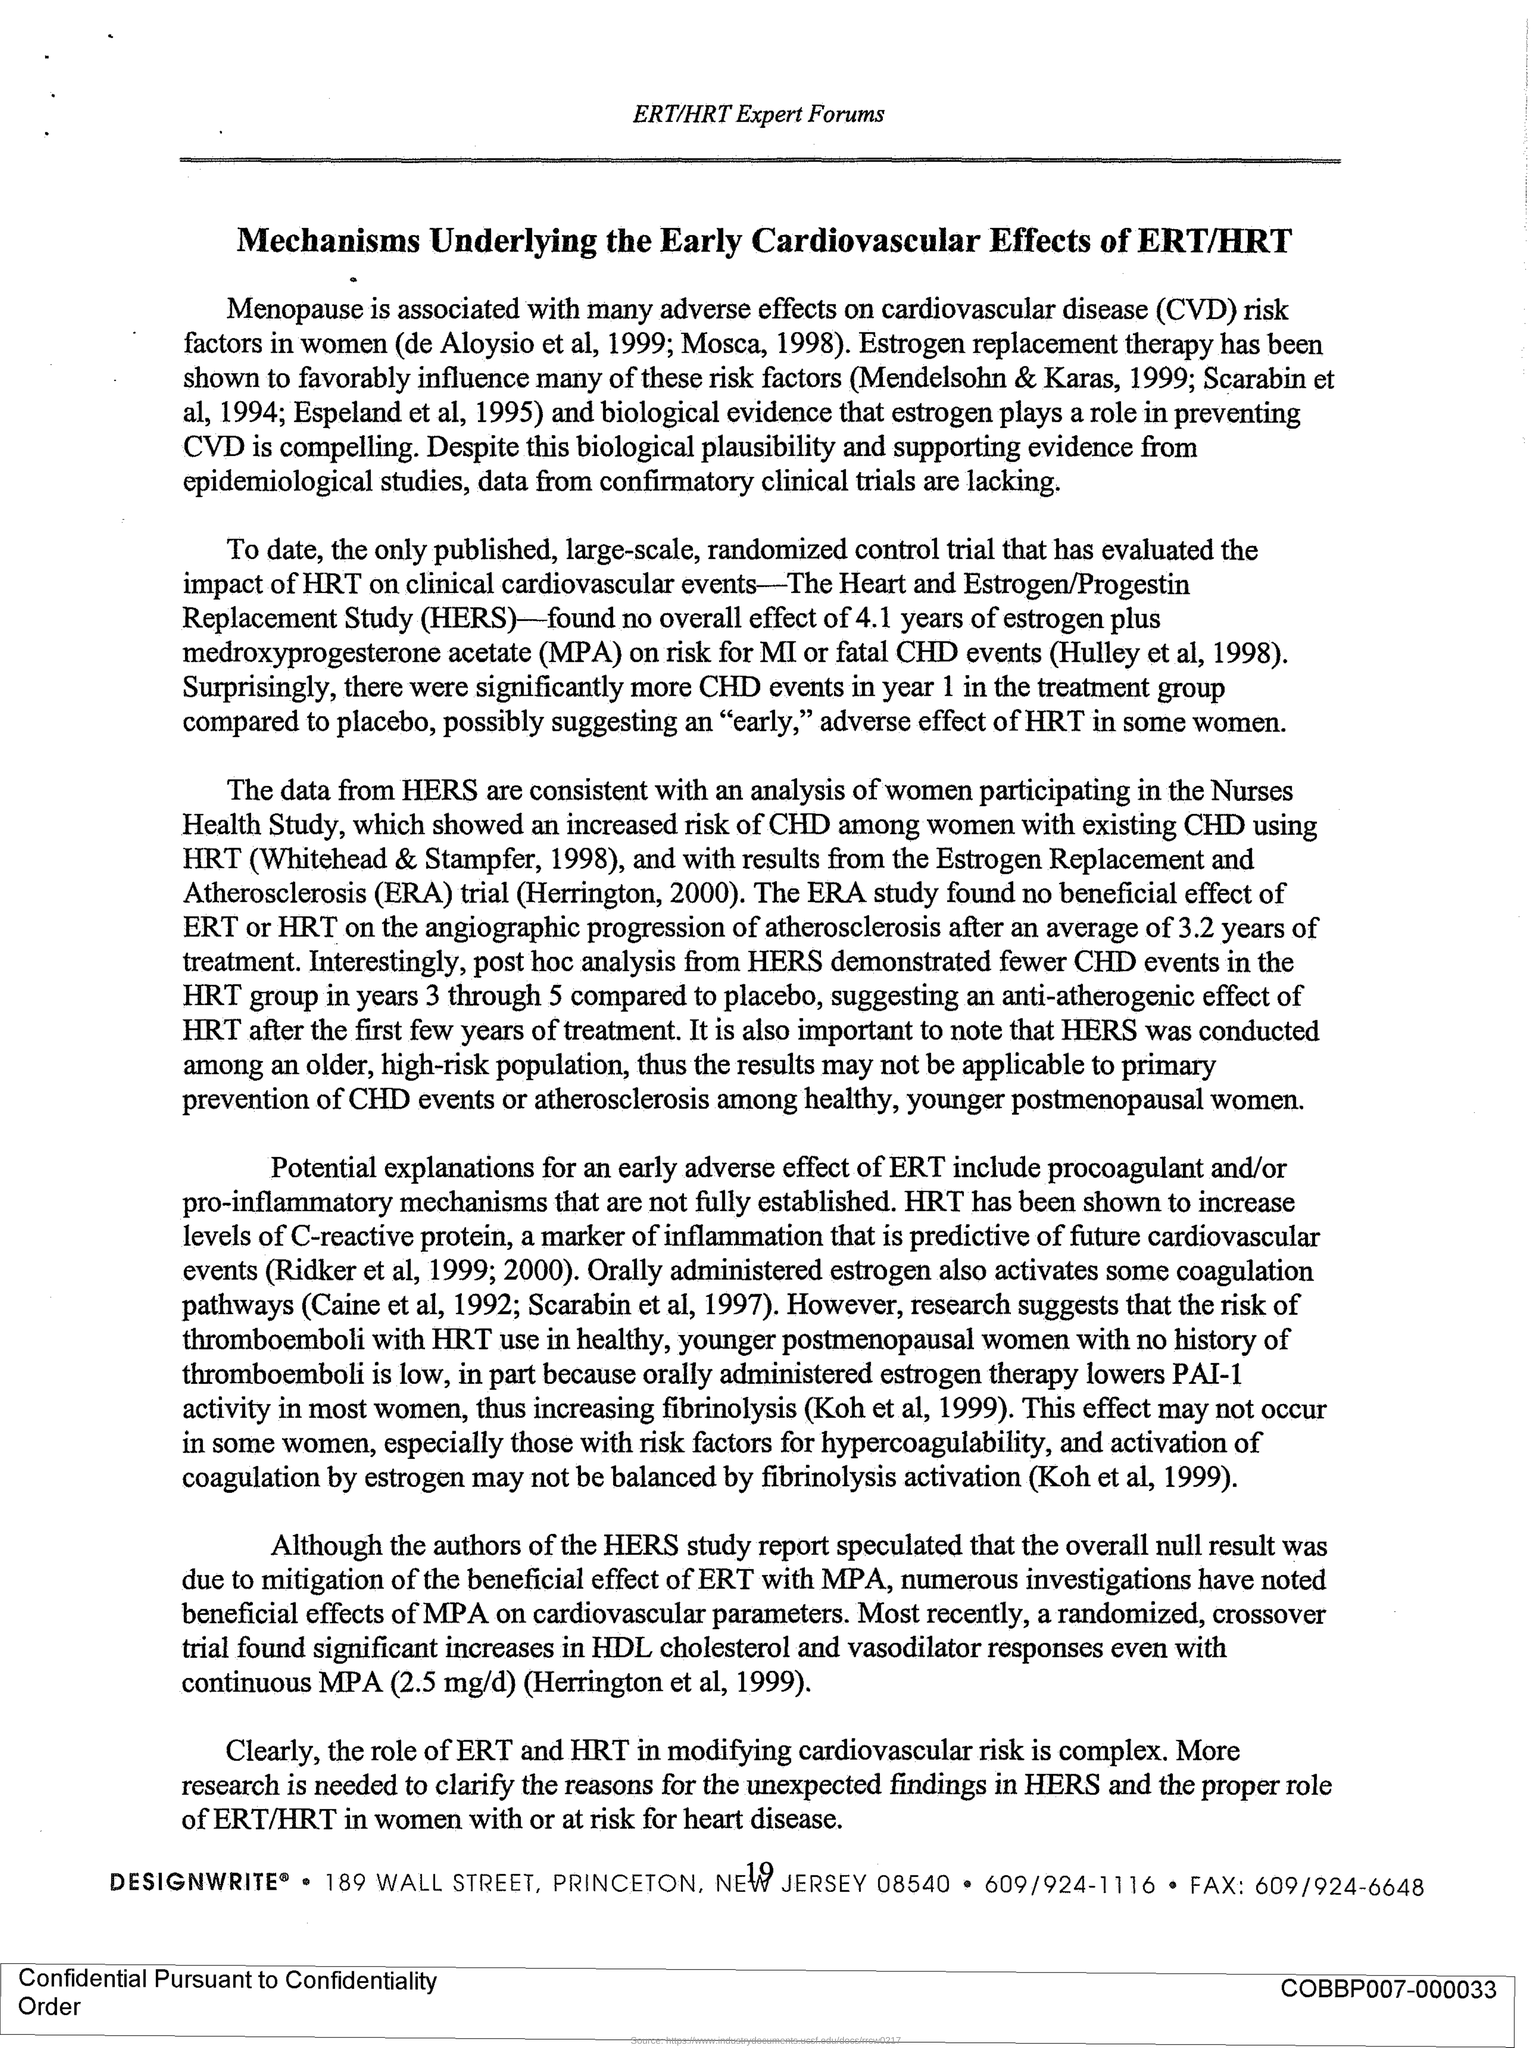What is the title of this document?
Your answer should be compact. Mechanisms Underlying the Early Cardiovascular Effects of ERT/HRT. What is the fullform of CVD?
Give a very brief answer. Cardiovascular disease. What is the abbreviation for 'The Heart and Estrogen/Progestin Replacement Study'?
Your answer should be compact. HERS. Which forum is mentioned in the header of the document?
Your response must be concise. ERT/HRT Expert Forums. 